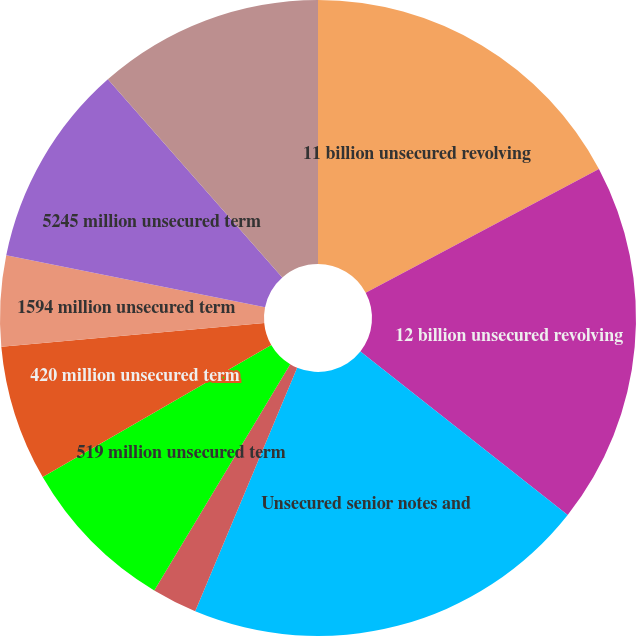Convert chart. <chart><loc_0><loc_0><loc_500><loc_500><pie_chart><fcel>11 billion unsecured revolving<fcel>12 billion unsecured revolving<fcel>Unsecured senior notes and<fcel>530 million unsecured term<fcel>519 million unsecured term<fcel>420 million unsecured term<fcel>1594 million unsecured term<fcel>5245 million unsecured term<fcel>5661 million unsecured term<nl><fcel>17.24%<fcel>18.39%<fcel>20.68%<fcel>2.3%<fcel>8.05%<fcel>6.9%<fcel>4.6%<fcel>10.35%<fcel>11.49%<nl></chart> 